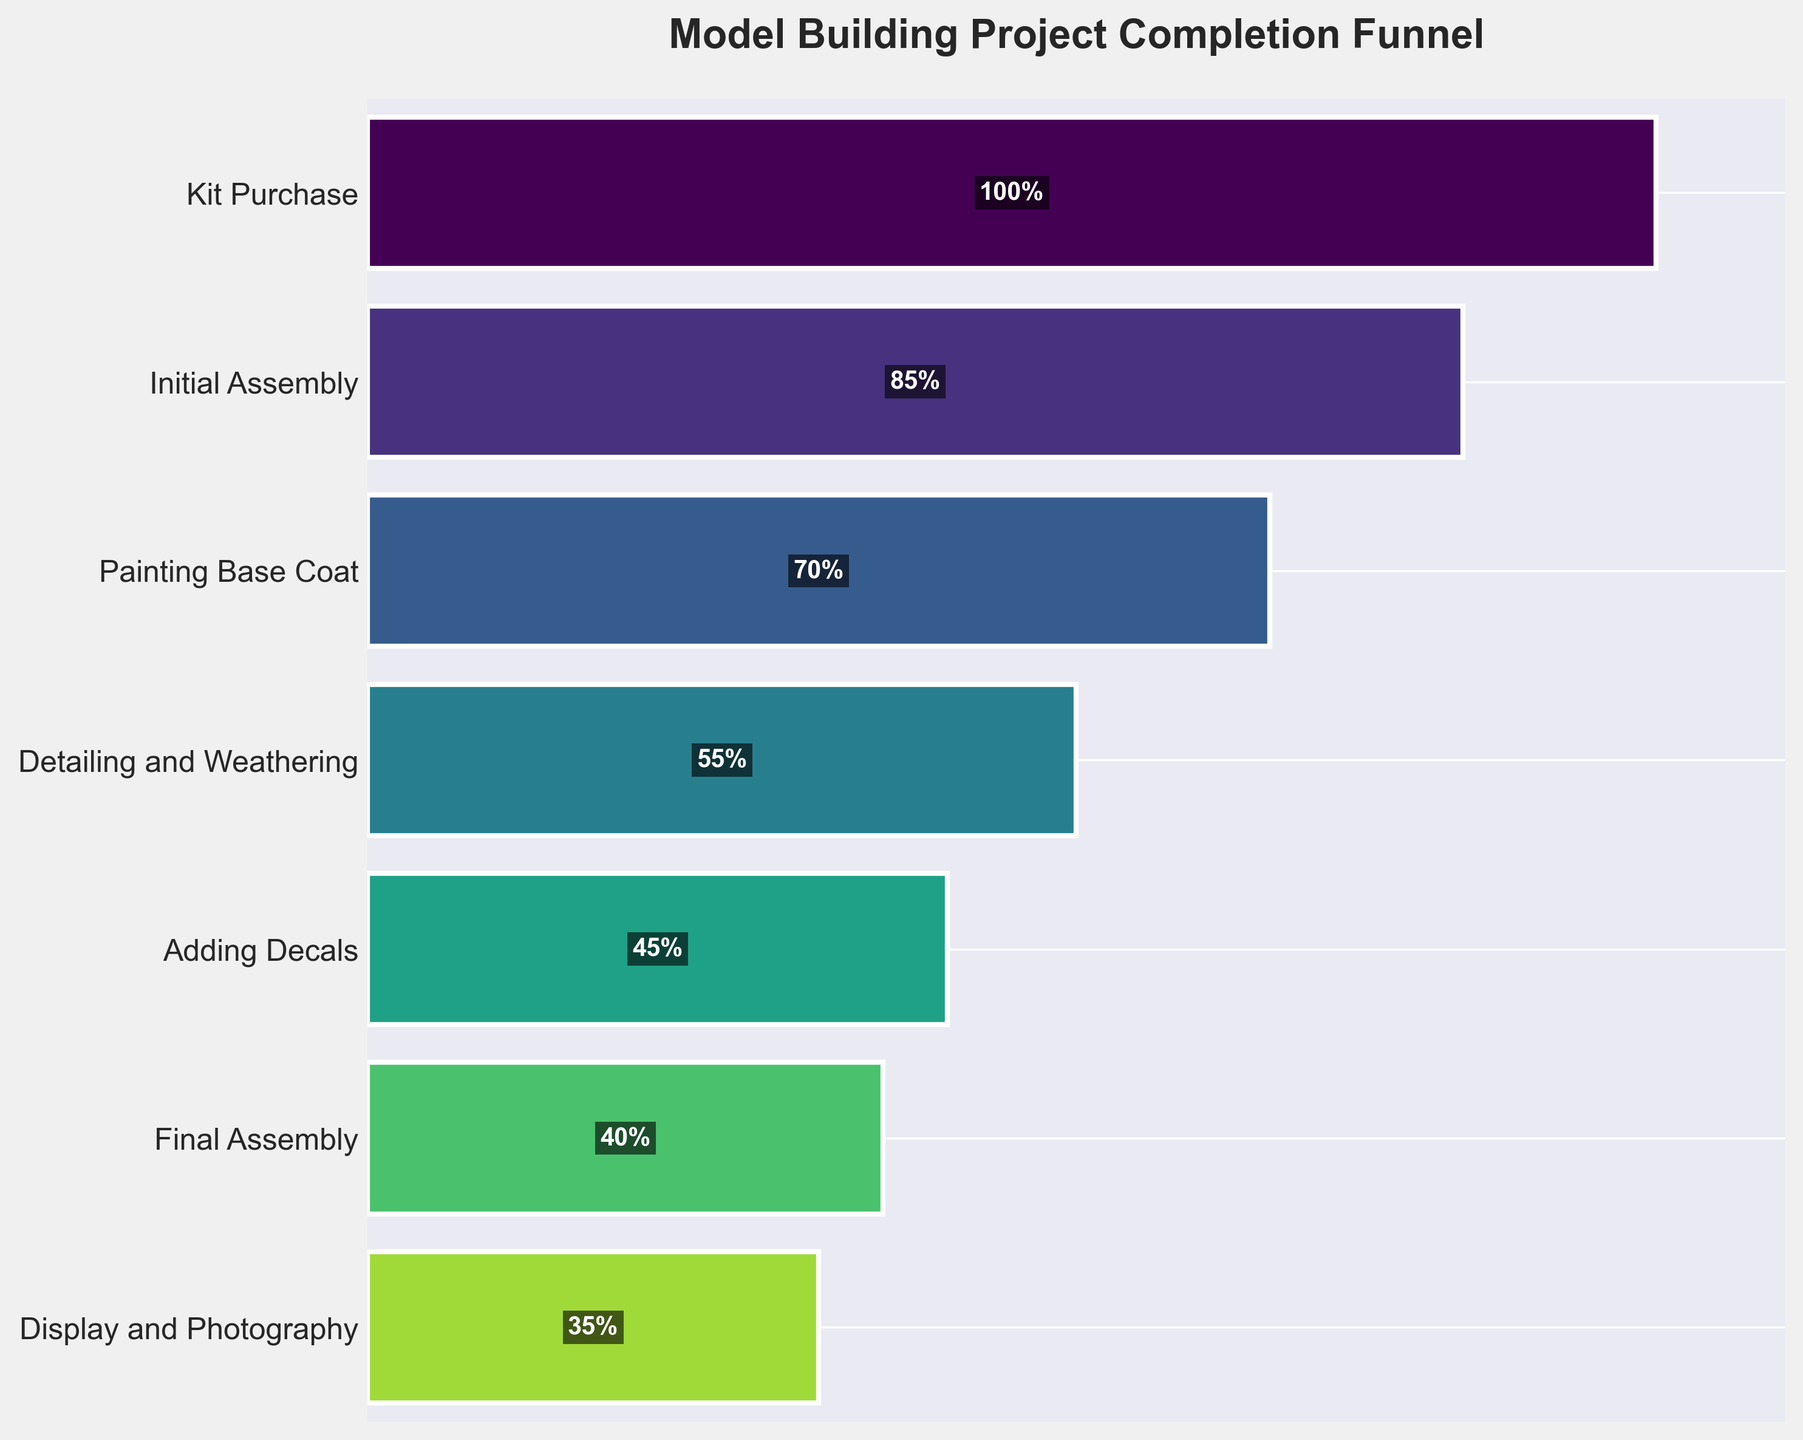What is the percentage at the Kit Purchase stage? The Kit Purchase stage is located at the top of the funnel chart. It is labeled with "100%" in the first row.
Answer: 100% Which stage has the lowest completion rate? The lowest completion rate is indicated by the narrowest part of the funnel and is labeled with the percentage. The Display and Photography stage has a 35% completion rate.
Answer: Display and Photography How many stages are represented in the funnel chart? Count the number of distinct stages listed on the y-axis of the funnel chart. There are seven stages in the chart.
Answer: 7 What percentage of kits make it to the Initial Assembly stage? The Initial Assembly stage is labeled and positioned below Kit Purchase. It shows 85% completion.
Answer: 85% Compare the completion rates between the Painting Base Coat and Detailing and Weathering stages. Painting Base Coat is at 70% and Detailing and Weathering is at 55%.
Answer: Painting Base Coat has a higher completion rate than Detailing and Weathering What is the average completion rate across all stages? Add the percentages of all stages: (100 + 85 + 70 + 55 + 45 + 40 + 35) and then divide by the number of stages (7). (100 + 85 + 70 + 55 + 45 + 40 + 35) / 7 = 430 / 7 = 61.43%.
Answer: 61.43% By how much does the completion rate drop from Kit Purchase to Initial Assembly? Subtract the completion percentage of Initial Assembly from Kit Purchase: 100% - 85% = 15%.
Answer: 15% Is the percentage drop from Initial Assembly to Painting Base Coat greater than or less than the drop from Painting Base Coat to Detailing and Weathering? Calculate both drops: 85% - 70% = 15% (Initial Assembly to Painting Base Coat) and 70% - 55% = 15% (Painting Base Coat to Detailing and Weathering); they are equal.
Answer: Equal How much does the completion rate decrease from Adding Decals to Display and Photography? Subtract the completion percentage of Display and Photography from Adding Decals: 45% - 35% = 10%.
Answer: 10% What percentage of kits reach the Final Assembly stage? The Final Assembly stage is labeled in the chart, showing a completion rate of 40%.
Answer: 40% 